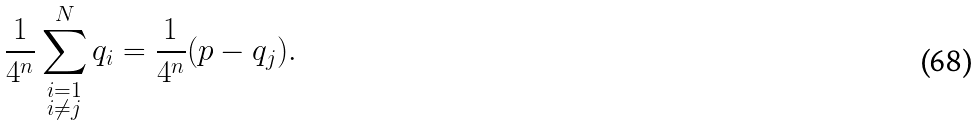<formula> <loc_0><loc_0><loc_500><loc_500>\frac { 1 } { 4 ^ { n } } \sum _ { \substack { i = 1 \\ i \neq j } } ^ { N } q _ { i } = \frac { 1 } { 4 ^ { n } } ( p - q _ { j } ) .</formula> 